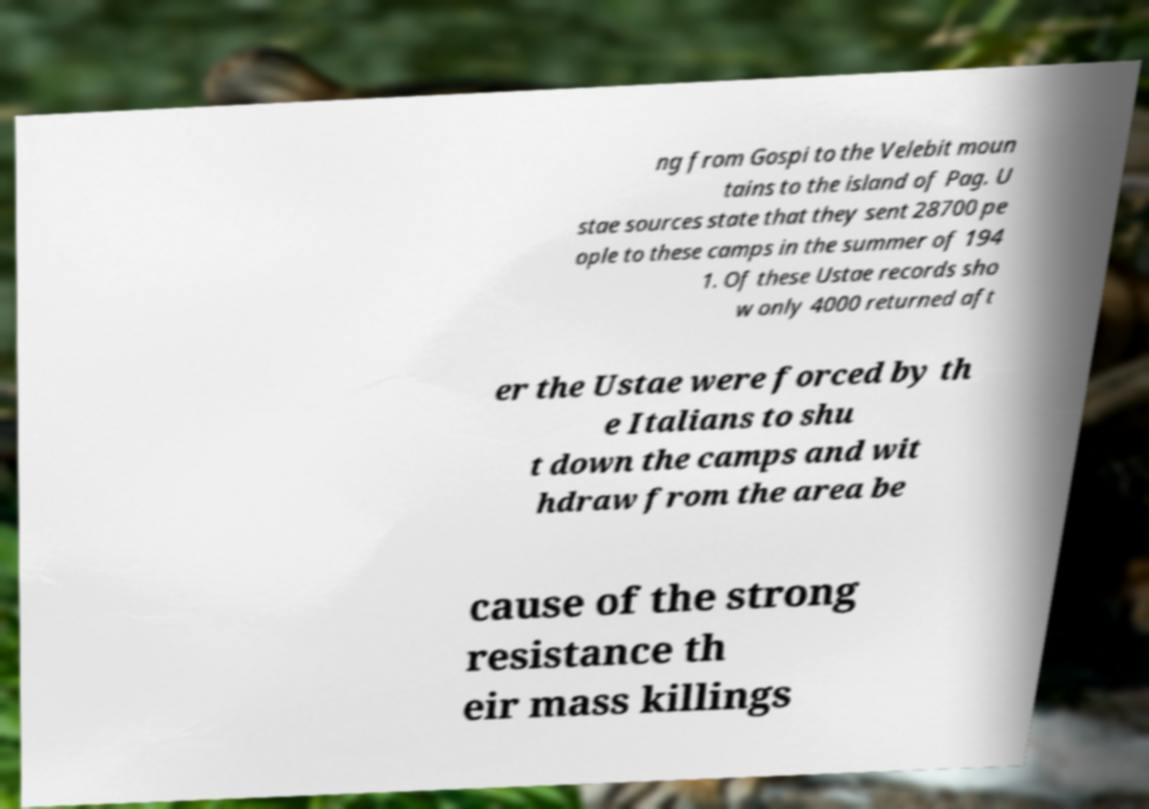There's text embedded in this image that I need extracted. Can you transcribe it verbatim? ng from Gospi to the Velebit moun tains to the island of Pag. U stae sources state that they sent 28700 pe ople to these camps in the summer of 194 1. Of these Ustae records sho w only 4000 returned aft er the Ustae were forced by th e Italians to shu t down the camps and wit hdraw from the area be cause of the strong resistance th eir mass killings 